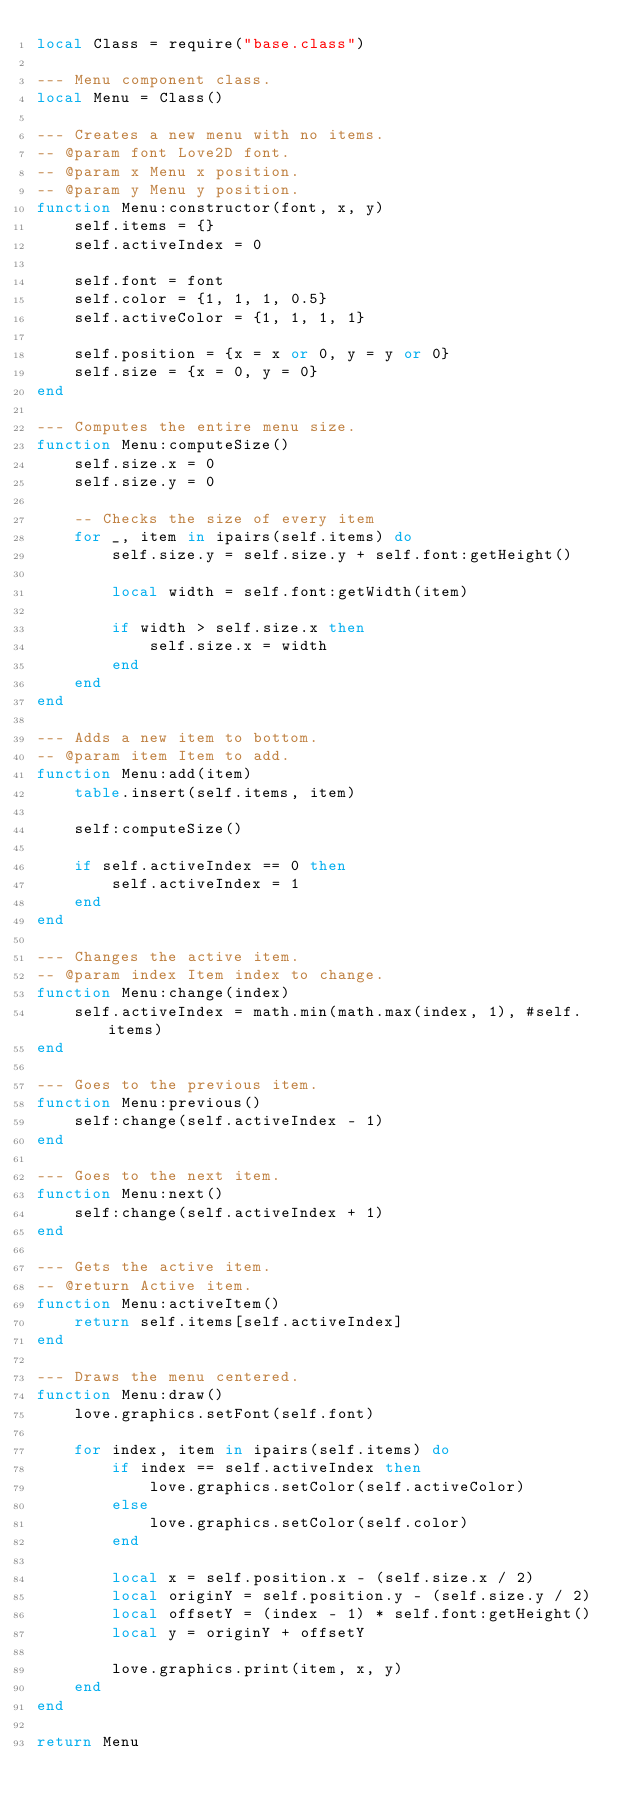<code> <loc_0><loc_0><loc_500><loc_500><_Lua_>local Class = require("base.class")

--- Menu component class.
local Menu = Class()

--- Creates a new menu with no items.
-- @param font Love2D font.
-- @param x Menu x position.
-- @param y Menu y position.
function Menu:constructor(font, x, y)
	self.items = {}
	self.activeIndex = 0

	self.font = font
	self.color = {1, 1, 1, 0.5}
	self.activeColor = {1, 1, 1, 1}

	self.position = {x = x or 0, y = y or 0}
	self.size = {x = 0, y = 0}
end

--- Computes the entire menu size.
function Menu:computeSize()
	self.size.x = 0
	self.size.y = 0

	-- Checks the size of every item
	for _, item in ipairs(self.items) do
		self.size.y = self.size.y + self.font:getHeight()

		local width = self.font:getWidth(item)

		if width > self.size.x then
			self.size.x = width
		end
	end
end

--- Adds a new item to bottom.
-- @param item Item to add.
function Menu:add(item)
	table.insert(self.items, item)

	self:computeSize()

	if self.activeIndex == 0 then
		self.activeIndex = 1
	end
end

--- Changes the active item.
-- @param index Item index to change.
function Menu:change(index)
	self.activeIndex = math.min(math.max(index, 1), #self.items)
end

--- Goes to the previous item.
function Menu:previous()
	self:change(self.activeIndex - 1)
end

--- Goes to the next item.
function Menu:next()
	self:change(self.activeIndex + 1)
end

--- Gets the active item.
-- @return Active item.
function Menu:activeItem()
	return self.items[self.activeIndex]
end

--- Draws the menu centered.
function Menu:draw()
	love.graphics.setFont(self.font)

	for index, item in ipairs(self.items) do
		if index == self.activeIndex then
			love.graphics.setColor(self.activeColor)
		else
			love.graphics.setColor(self.color)
		end

		local x = self.position.x - (self.size.x / 2)
		local originY = self.position.y - (self.size.y / 2)
		local offsetY = (index - 1) * self.font:getHeight()
		local y = originY + offsetY

		love.graphics.print(item, x, y)
	end
end

return Menu
</code> 